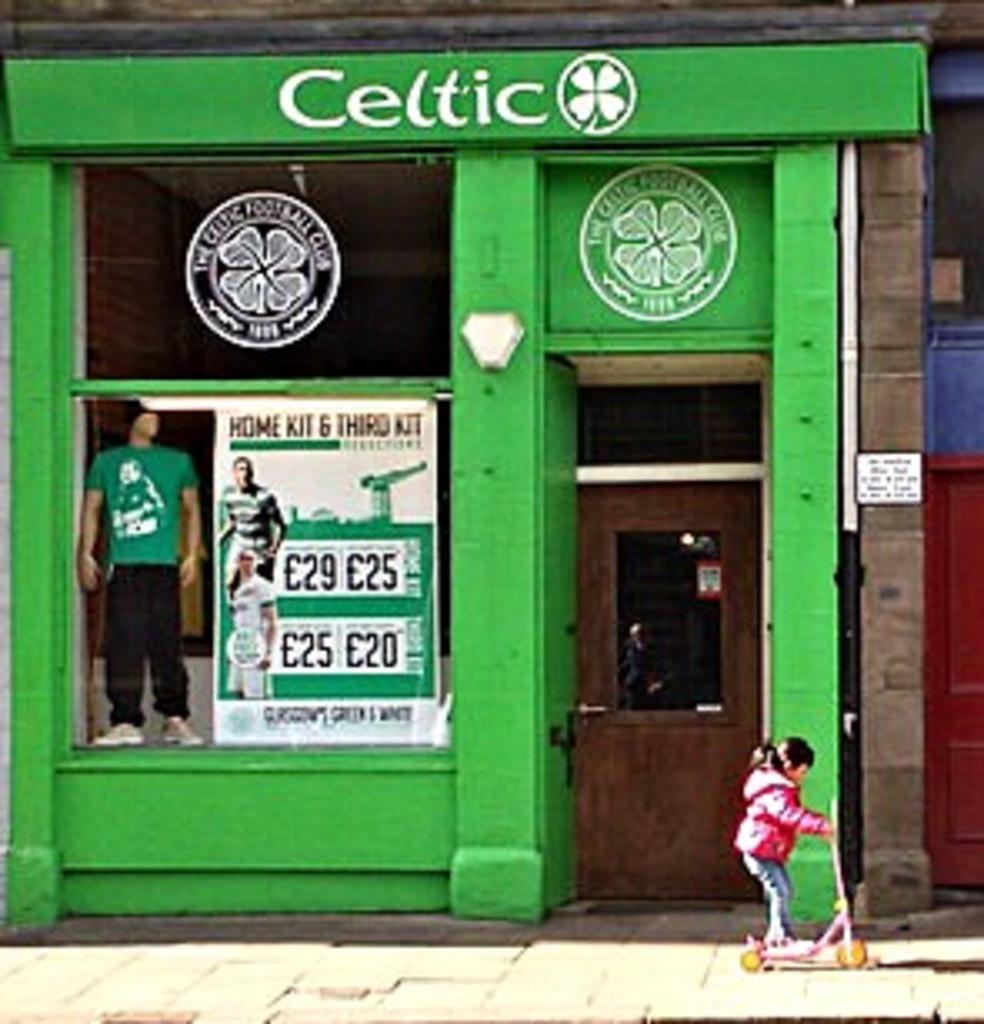What is the name of this business?
Your answer should be very brief. Celtic. This business name is what color?
Your answer should be compact. White. 